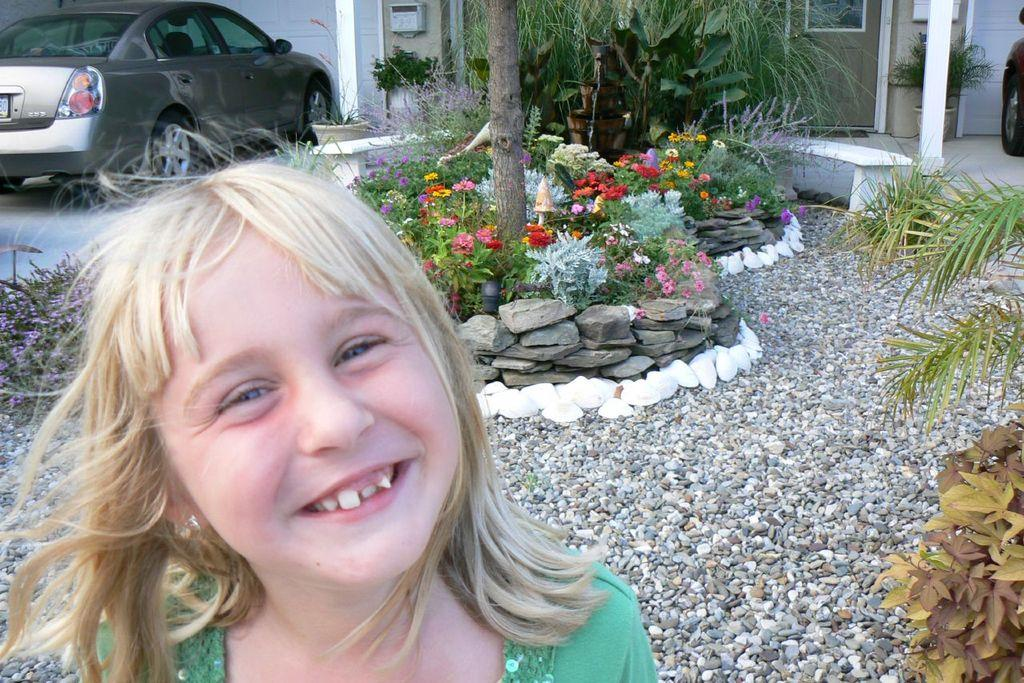Who is the main subject in the image? There is a girl in the center of the image. What can be seen in the background of the image? There are stones, trees, plants, flowers, windows, a car, a road, and a house in the background of the image. Can you describe the natural elements in the background? The background includes trees, plants, and flowers. What type of man-made structures are visible in the background? There are windows, a car, a road, and a house in the background. What type of bird can be heard singing in the image? There is no bird present or singing in the image. How does the snail affect the acoustics of the image? There is no snail present in the image, so it cannot affect the acoustics. 